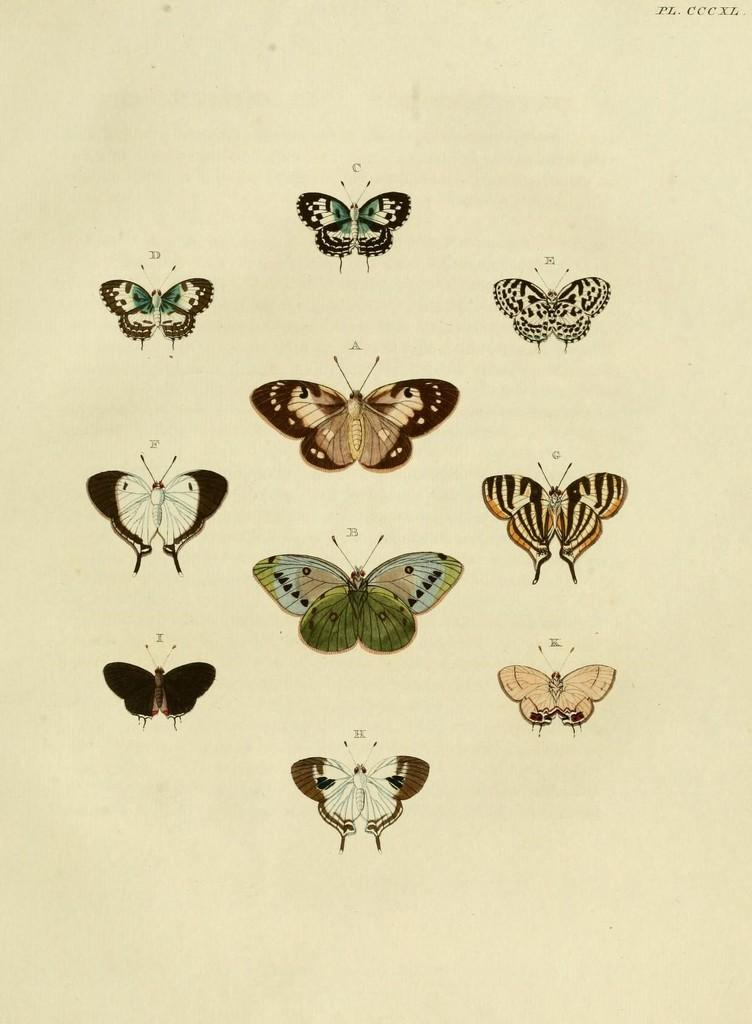What type of animals are depicted in the images in the picture? The images contain pictures of butterflies. How many seats are visible in the image? There are no seats visible in the image, as it only contains pictures of butterflies. What type of hands can be seen interacting with the butterflies in the image? There are no hands visible in the image, as it only contains pictures of butterflies. 